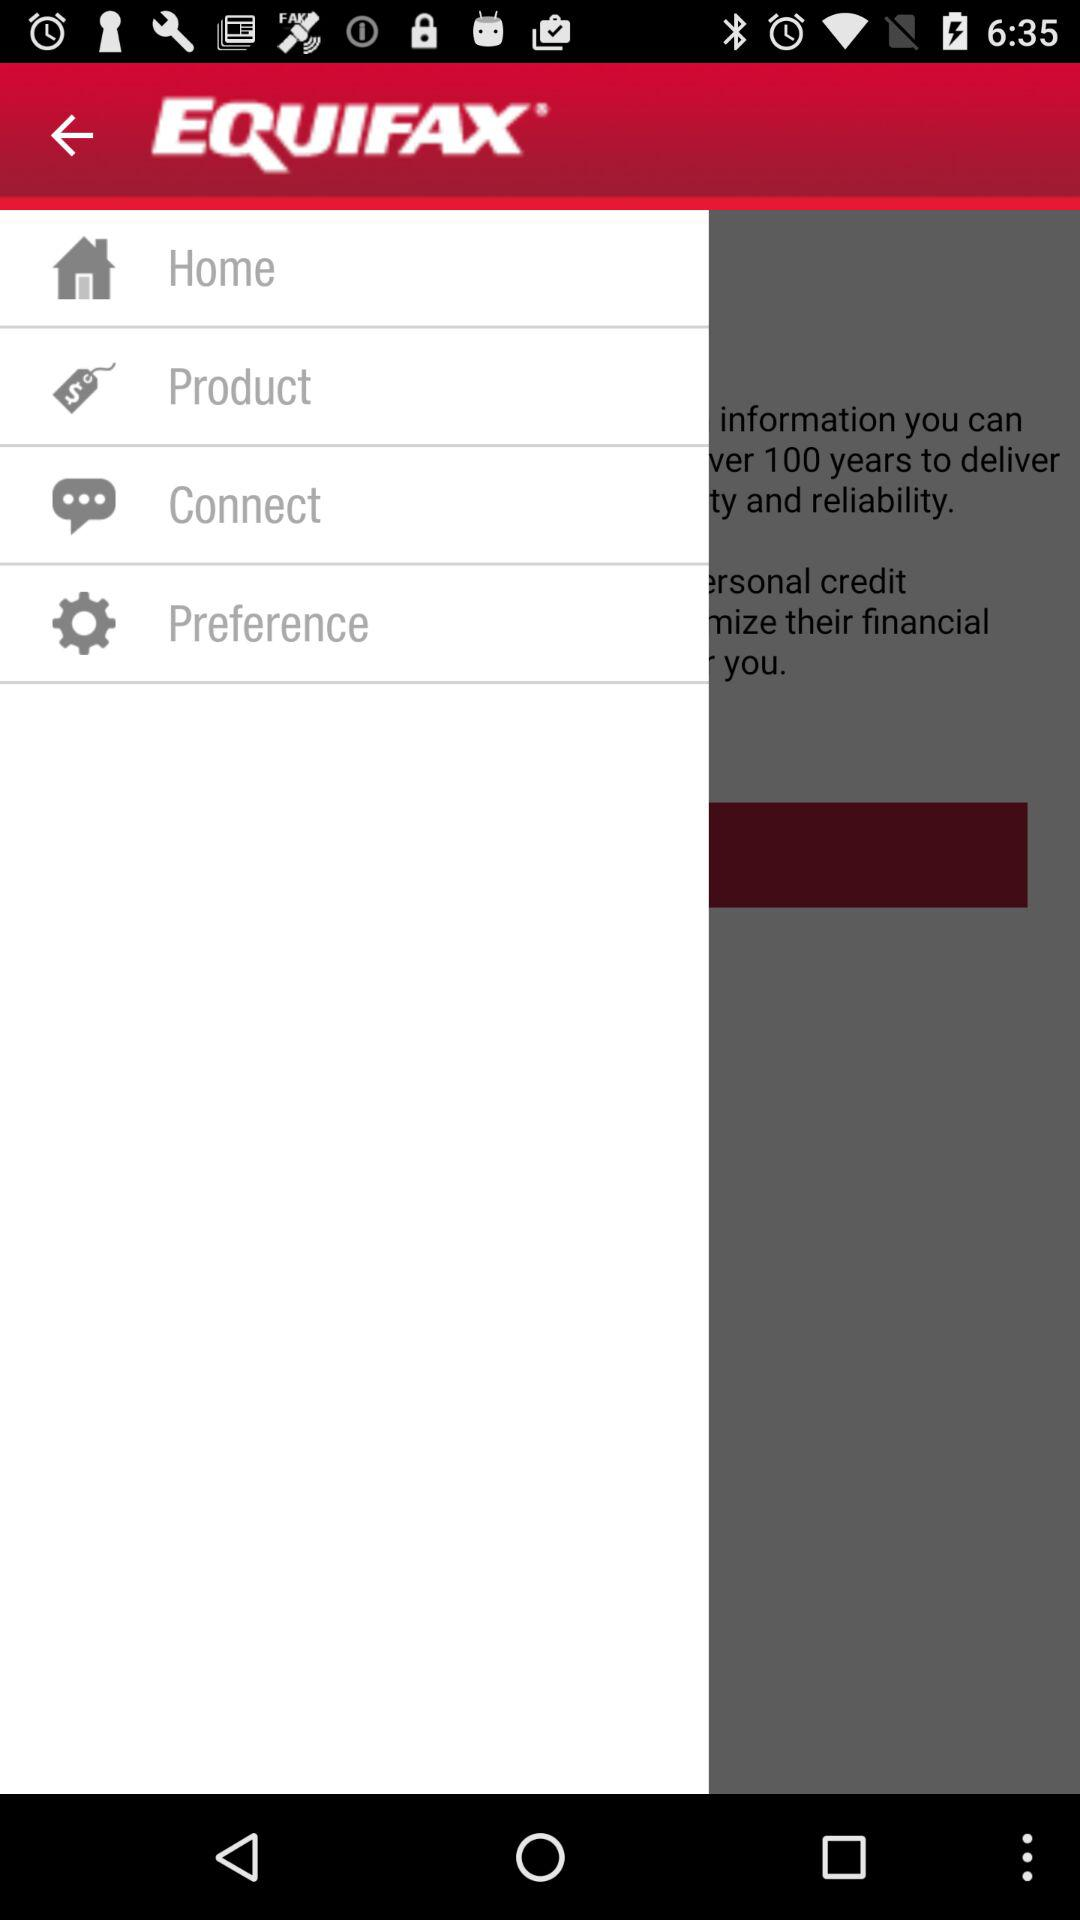What is the app name? The app name is "EQUIFAX". 